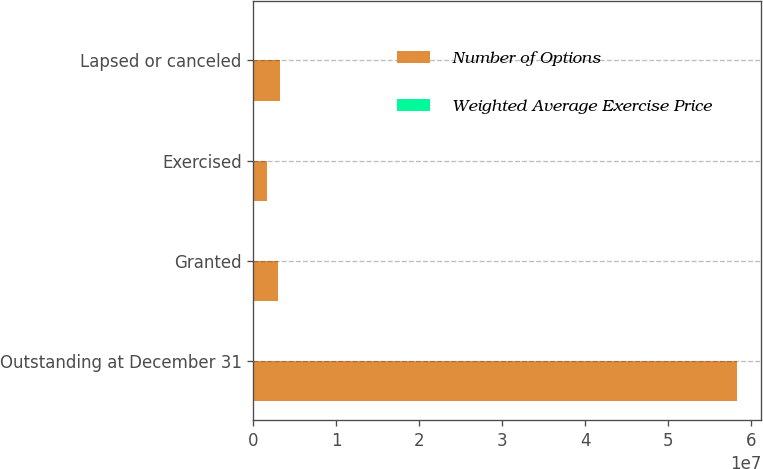Convert chart to OTSL. <chart><loc_0><loc_0><loc_500><loc_500><stacked_bar_chart><ecel><fcel>Outstanding at December 31<fcel>Granted<fcel>Exercised<fcel>Lapsed or canceled<nl><fcel>Number of Options<fcel>5.83189e+07<fcel>2.996e+06<fcel>1.692e+06<fcel>3.16892e+06<nl><fcel>Weighted Average Exercise Price<fcel>38.09<fcel>33.61<fcel>18.15<fcel>43.14<nl></chart> 